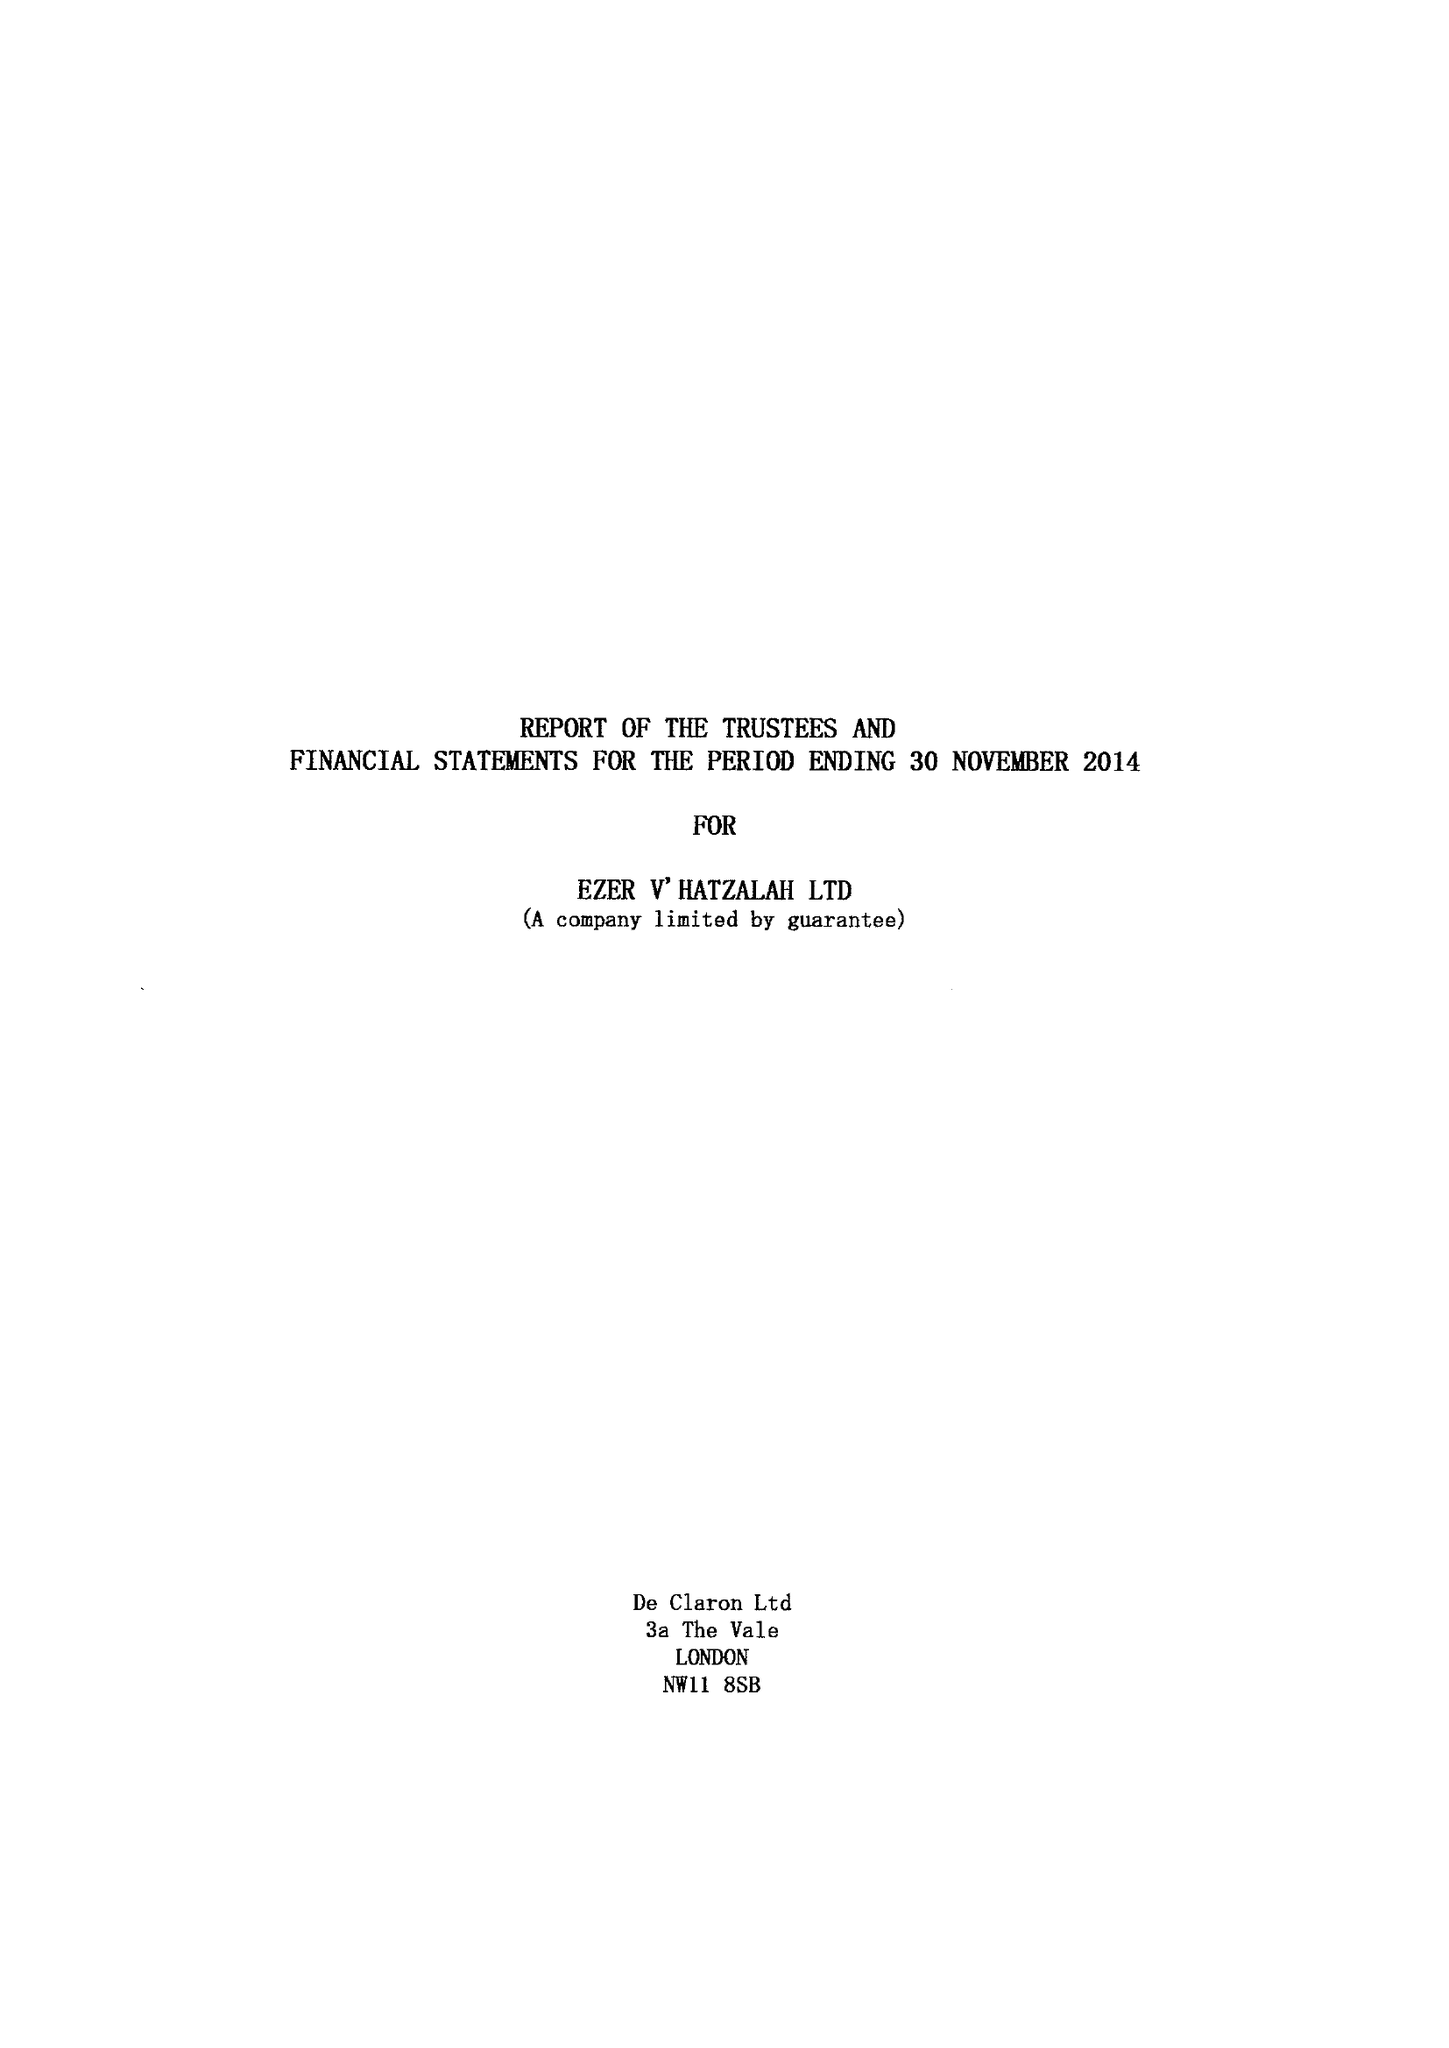What is the value for the report_date?
Answer the question using a single word or phrase. 2014-11-30 